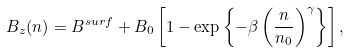<formula> <loc_0><loc_0><loc_500><loc_500>B _ { z } ( n ) = B ^ { s u r f } + B _ { 0 } \left [ 1 - \exp \left \{ - \beta \left ( \frac { n } { n _ { 0 } } \right ) ^ { \gamma } \right \} \right ] ,</formula> 